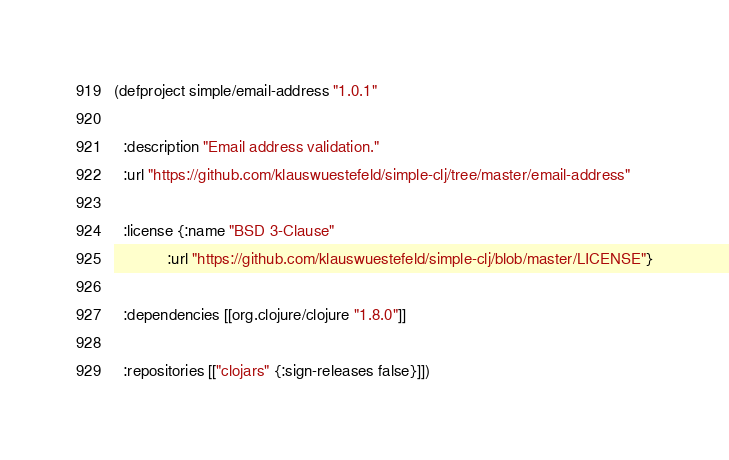<code> <loc_0><loc_0><loc_500><loc_500><_Clojure_>(defproject simple/email-address "1.0.1"

  :description "Email address validation."
  :url "https://github.com/klauswuestefeld/simple-clj/tree/master/email-address"

  :license {:name "BSD 3-Clause"
            :url "https://github.com/klauswuestefeld/simple-clj/blob/master/LICENSE"}

  :dependencies [[org.clojure/clojure "1.8.0"]]

  :repositories [["clojars" {:sign-releases false}]])
</code> 